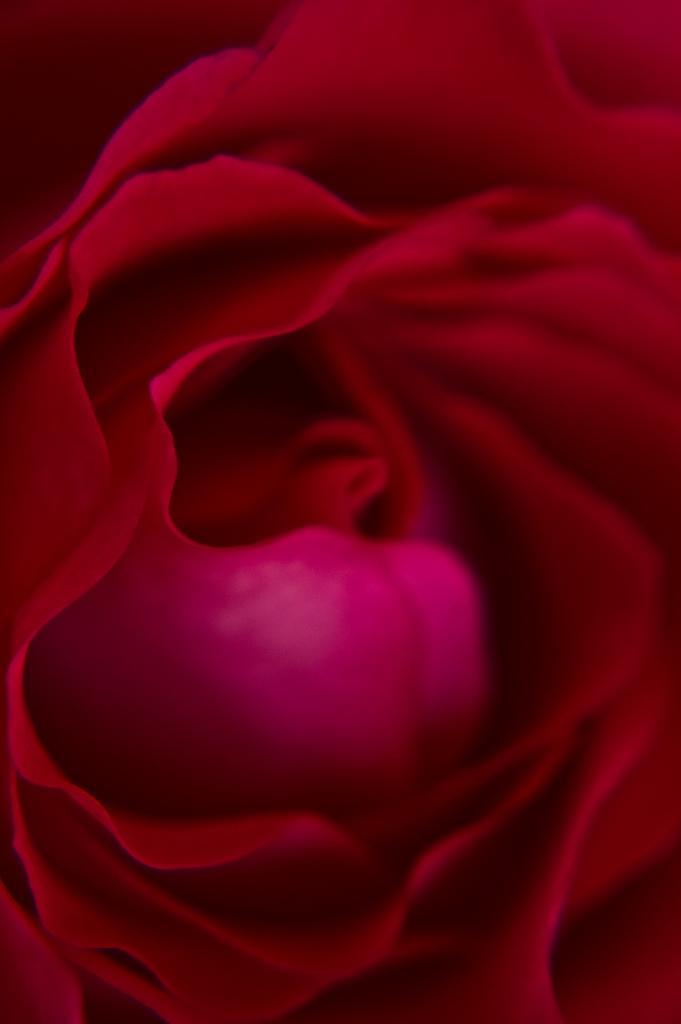Please provide a concise description of this image. In this image I can see the flower which is in red color. 